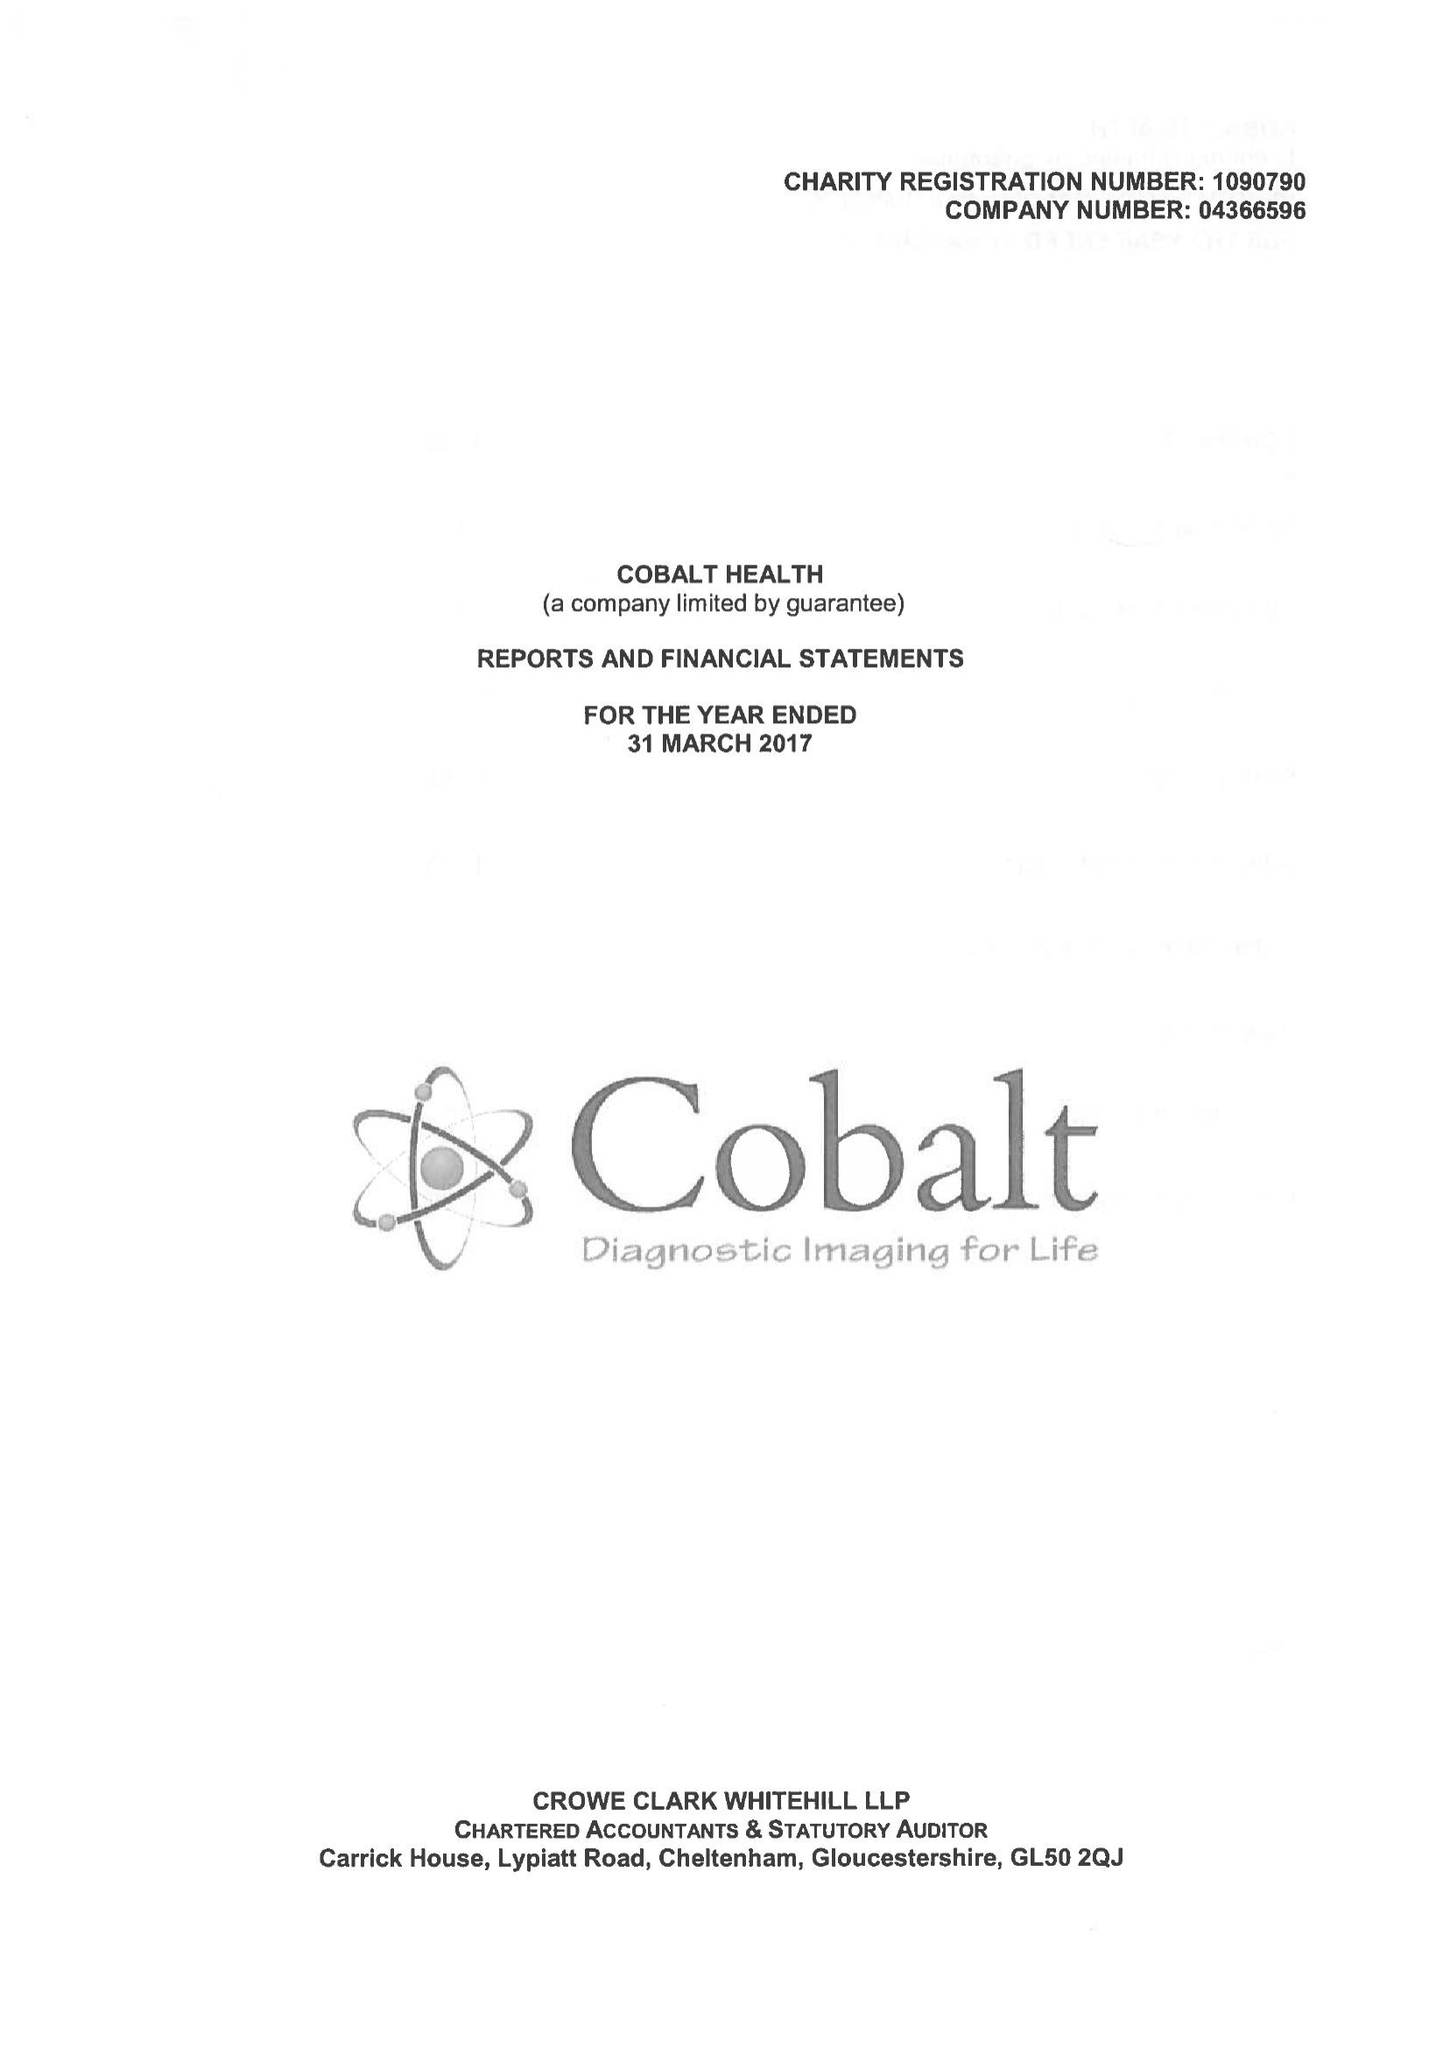What is the value for the report_date?
Answer the question using a single word or phrase. 2017-03-31 